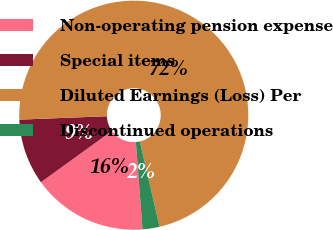<chart> <loc_0><loc_0><loc_500><loc_500><pie_chart><fcel>Non-operating pension expense<fcel>Special items<fcel>Diluted Earnings (Loss) Per<fcel>Discontinued operations<nl><fcel>16.27%<fcel>9.33%<fcel>72.01%<fcel>2.39%<nl></chart> 